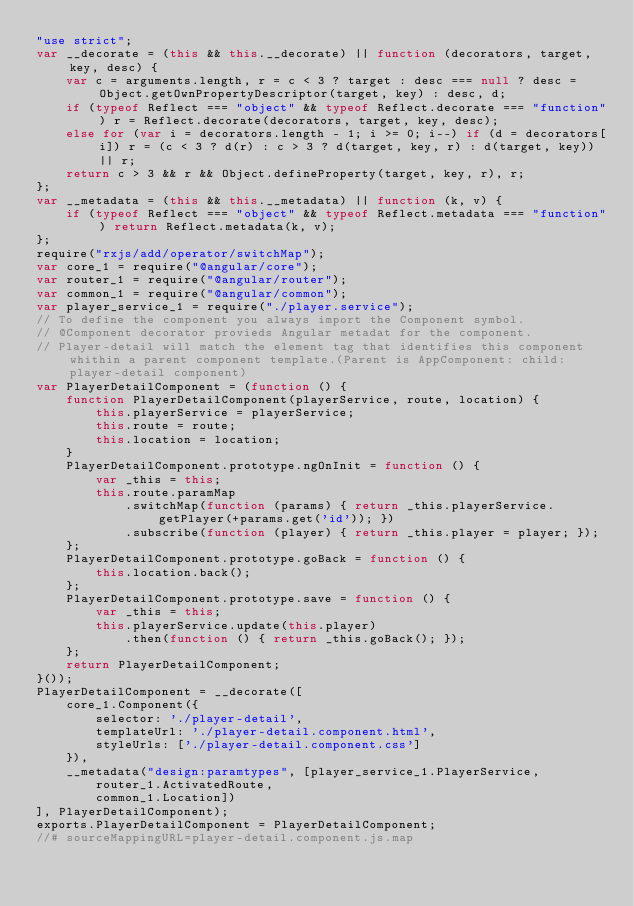<code> <loc_0><loc_0><loc_500><loc_500><_JavaScript_>"use strict";
var __decorate = (this && this.__decorate) || function (decorators, target, key, desc) {
    var c = arguments.length, r = c < 3 ? target : desc === null ? desc = Object.getOwnPropertyDescriptor(target, key) : desc, d;
    if (typeof Reflect === "object" && typeof Reflect.decorate === "function") r = Reflect.decorate(decorators, target, key, desc);
    else for (var i = decorators.length - 1; i >= 0; i--) if (d = decorators[i]) r = (c < 3 ? d(r) : c > 3 ? d(target, key, r) : d(target, key)) || r;
    return c > 3 && r && Object.defineProperty(target, key, r), r;
};
var __metadata = (this && this.__metadata) || function (k, v) {
    if (typeof Reflect === "object" && typeof Reflect.metadata === "function") return Reflect.metadata(k, v);
};
require("rxjs/add/operator/switchMap");
var core_1 = require("@angular/core");
var router_1 = require("@angular/router");
var common_1 = require("@angular/common");
var player_service_1 = require("./player.service");
// To define the component you always import the Component symbol.
// @Component decorator provieds Angular metadat for the component. 
// Player-detail will match the element tag that identifies this component whithin a parent component template.(Parent is AppComponent: child: player-detail component)
var PlayerDetailComponent = (function () {
    function PlayerDetailComponent(playerService, route, location) {
        this.playerService = playerService;
        this.route = route;
        this.location = location;
    }
    PlayerDetailComponent.prototype.ngOnInit = function () {
        var _this = this;
        this.route.paramMap
            .switchMap(function (params) { return _this.playerService.getPlayer(+params.get('id')); })
            .subscribe(function (player) { return _this.player = player; });
    };
    PlayerDetailComponent.prototype.goBack = function () {
        this.location.back();
    };
    PlayerDetailComponent.prototype.save = function () {
        var _this = this;
        this.playerService.update(this.player)
            .then(function () { return _this.goBack(); });
    };
    return PlayerDetailComponent;
}());
PlayerDetailComponent = __decorate([
    core_1.Component({
        selector: './player-detail',
        templateUrl: './player-detail.component.html',
        styleUrls: ['./player-detail.component.css']
    }),
    __metadata("design:paramtypes", [player_service_1.PlayerService,
        router_1.ActivatedRoute,
        common_1.Location])
], PlayerDetailComponent);
exports.PlayerDetailComponent = PlayerDetailComponent;
//# sourceMappingURL=player-detail.component.js.map</code> 